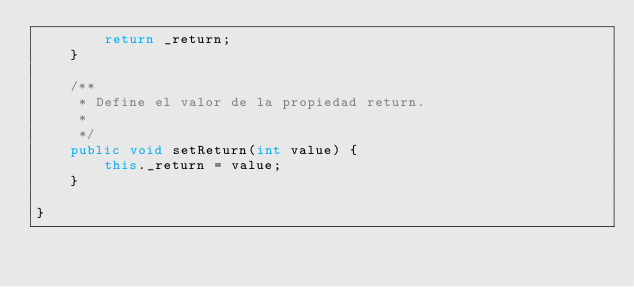<code> <loc_0><loc_0><loc_500><loc_500><_Java_>        return _return;
    }

    /**
     * Define el valor de la propiedad return.
     * 
     */
    public void setReturn(int value) {
        this._return = value;
    }

}
</code> 